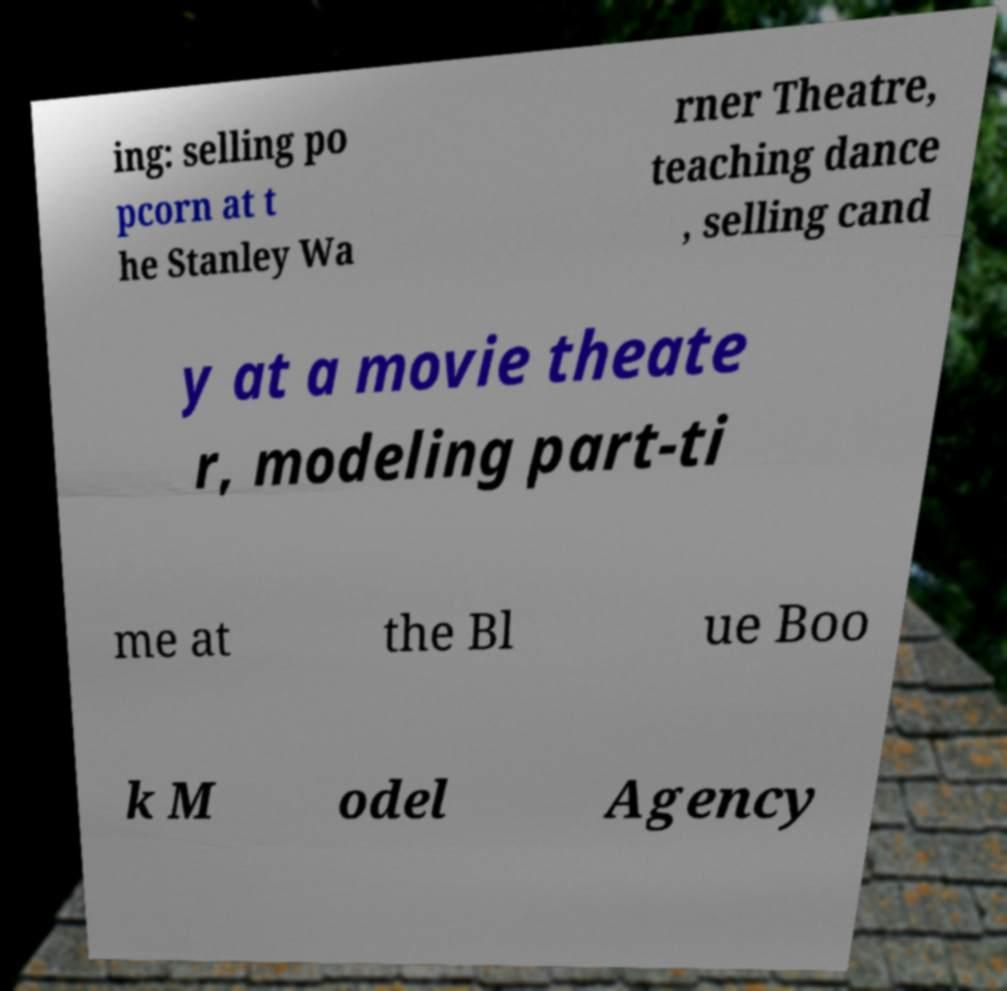Could you assist in decoding the text presented in this image and type it out clearly? ing: selling po pcorn at t he Stanley Wa rner Theatre, teaching dance , selling cand y at a movie theate r, modeling part-ti me at the Bl ue Boo k M odel Agency 